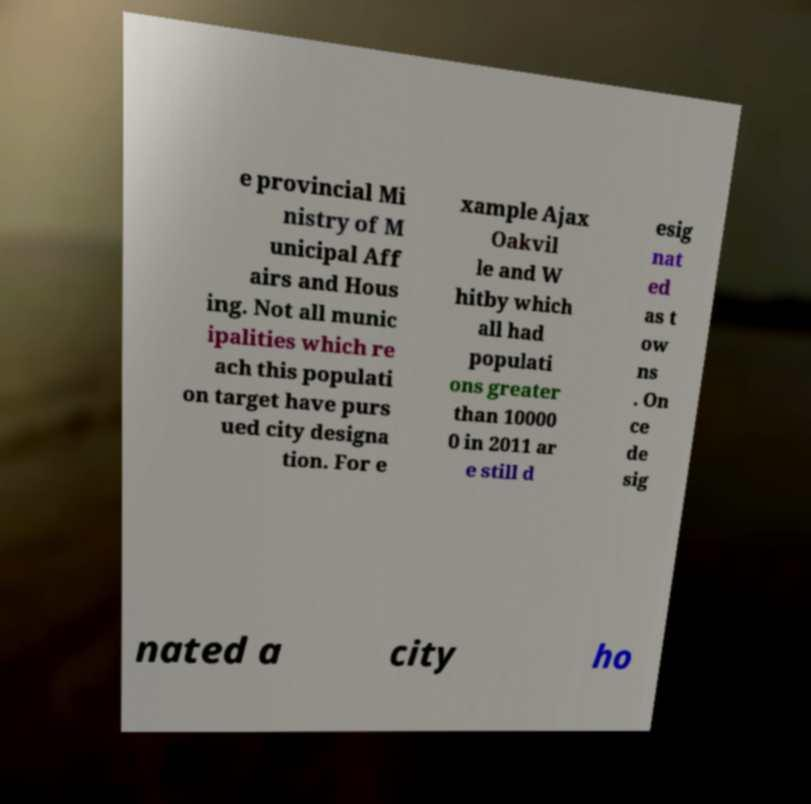Please read and relay the text visible in this image. What does it say? e provincial Mi nistry of M unicipal Aff airs and Hous ing. Not all munic ipalities which re ach this populati on target have purs ued city designa tion. For e xample Ajax Oakvil le and W hitby which all had populati ons greater than 10000 0 in 2011 ar e still d esig nat ed as t ow ns . On ce de sig nated a city ho 